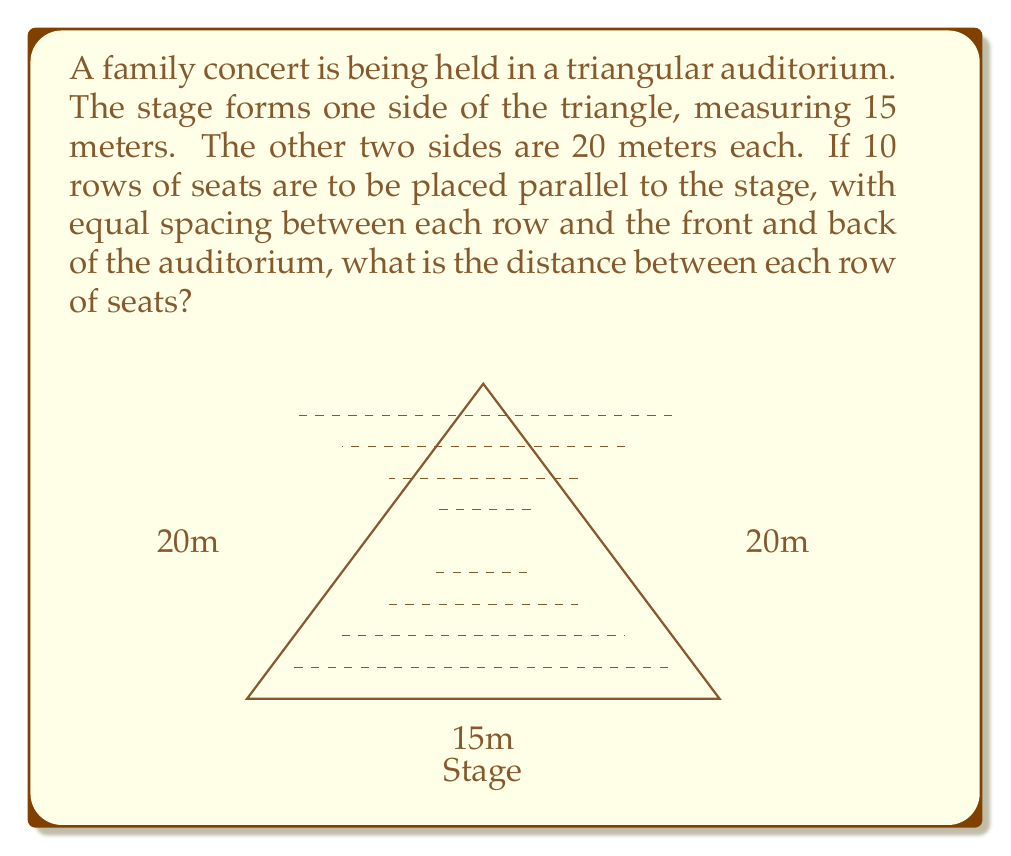Help me with this question. Let's approach this step-by-step:

1) First, we need to find the height of the triangular auditorium. We can use the Pythagorean theorem:

   $$(7.5)^2 + h^2 = 20^2$$
   $$56.25 + h^2 = 400$$
   $$h^2 = 343.75$$
   $$h = \sqrt{343.75} = 18.54\text{ meters}$$

2) Now, we need to divide this height into 11 equal parts (10 rows plus the spaces at the front and back):

   $$\text{Distance} = \frac{18.54}{11} = 1.685\text{ meters}$$

3) To verify:
   - Front space: 1.685 m
   - 10 rows: 10 * 1.685 = 16.85 m
   - Back space: 1.685 m
   Total: 1.685 + 16.85 + 1.685 = 20.22 m (slight difference due to rounding)

Therefore, the distance between each row of seats is approximately 1.685 meters.
Answer: $1.685\text{ meters}$ 